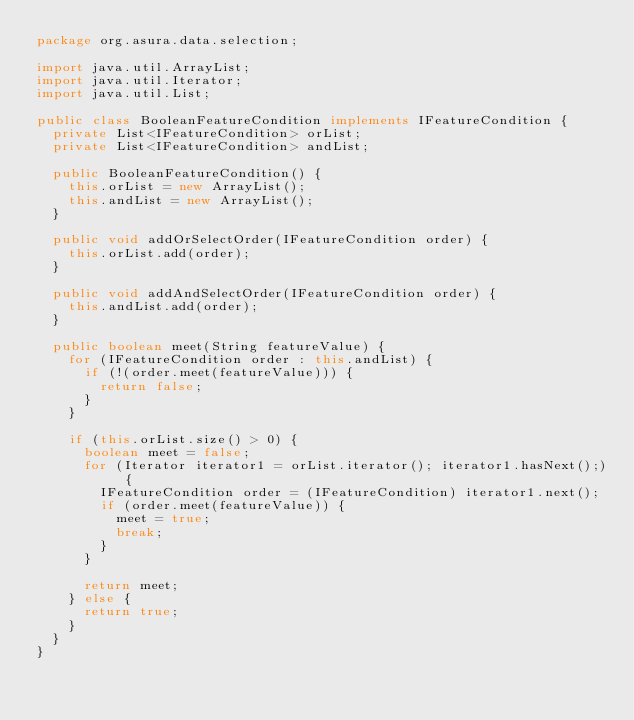Convert code to text. <code><loc_0><loc_0><loc_500><loc_500><_Java_>package org.asura.data.selection;

import java.util.ArrayList;
import java.util.Iterator;
import java.util.List;

public class BooleanFeatureCondition implements IFeatureCondition {
	private List<IFeatureCondition> orList;
	private List<IFeatureCondition> andList;

	public BooleanFeatureCondition() {
		this.orList = new ArrayList();
		this.andList = new ArrayList();
	}

	public void addOrSelectOrder(IFeatureCondition order) {
		this.orList.add(order);
	}

	public void addAndSelectOrder(IFeatureCondition order) {
		this.andList.add(order);
	}

	public boolean meet(String featureValue) {
		for (IFeatureCondition order : this.andList) {
			if (!(order.meet(featureValue))) {
				return false;
			}
		}

		if (this.orList.size() > 0) {
			boolean meet = false;
			for (Iterator iterator1 = orList.iterator(); iterator1.hasNext();) {
				IFeatureCondition order = (IFeatureCondition) iterator1.next();
				if (order.meet(featureValue)) {
					meet = true;
					break;
				}
			}

			return meet;
		} else {
			return true;
		}
	}
}
</code> 